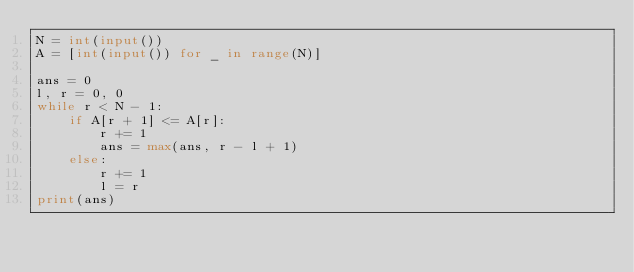<code> <loc_0><loc_0><loc_500><loc_500><_Python_>N = int(input())
A = [int(input()) for _ in range(N)]

ans = 0
l, r = 0, 0
while r < N - 1:
    if A[r + 1] <= A[r]:
        r += 1
        ans = max(ans, r - l + 1)
    else:
        r += 1
        l = r
print(ans)</code> 